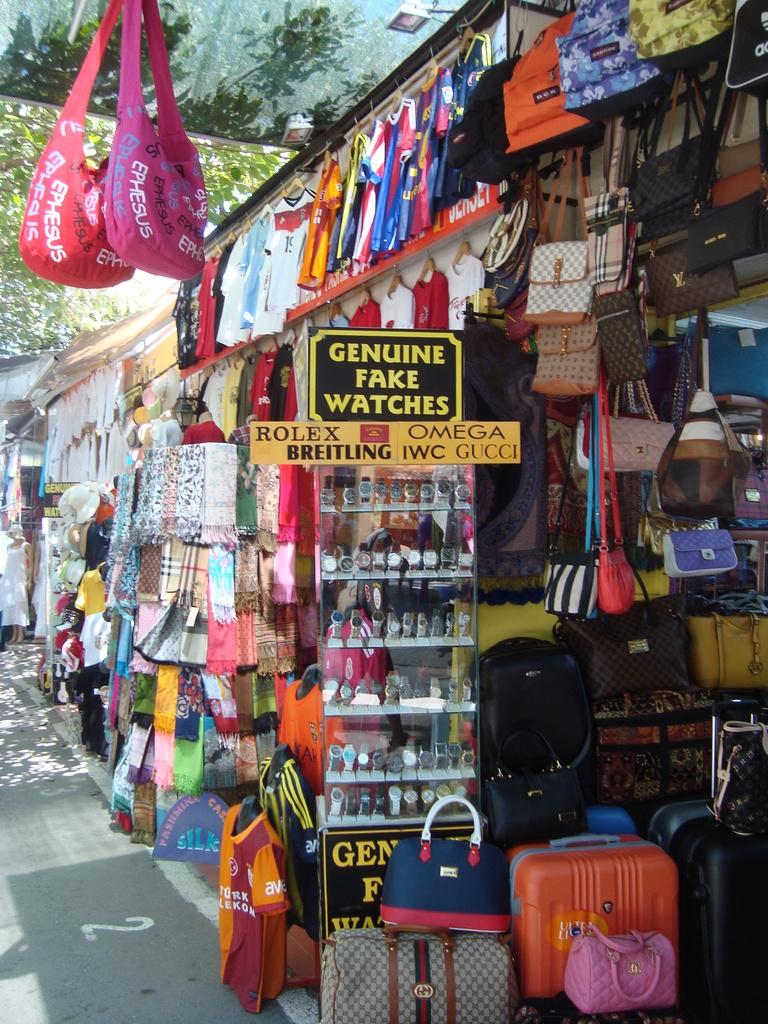Where was the image taken? The image was taken on a road. What type of shops can be seen in the image? The shops in the image are selling handbags and watches. What is the label on the shop in the image? The label on the shop in the image says "Genuine fake watches." What type of bread can be seen on the tray in the image? There is no tray or bread present in the image. 